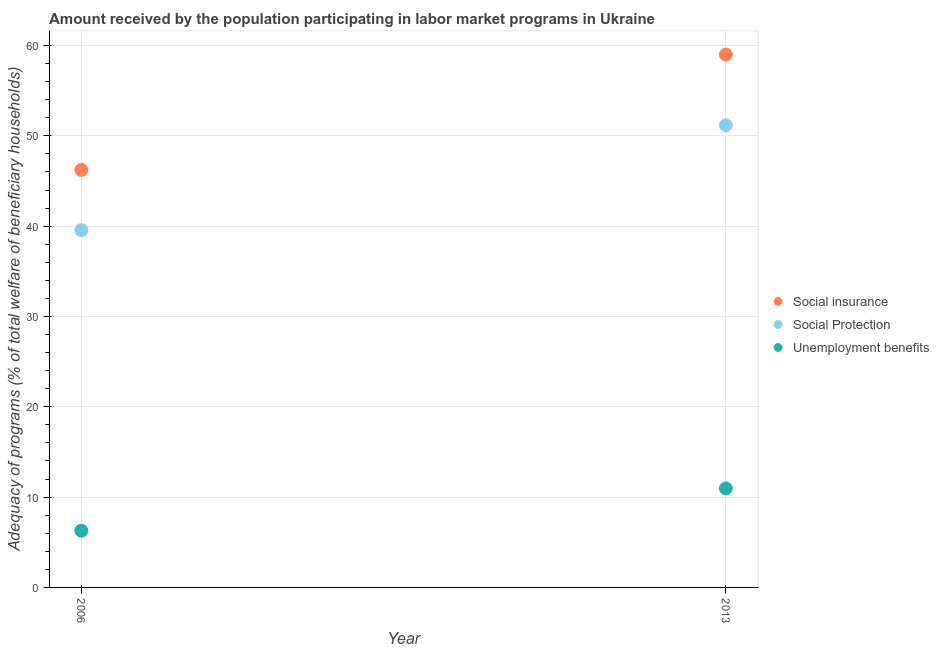How many different coloured dotlines are there?
Your answer should be very brief. 3. What is the amount received by the population participating in social insurance programs in 2006?
Offer a terse response. 46.23. Across all years, what is the maximum amount received by the population participating in social insurance programs?
Provide a short and direct response. 58.99. Across all years, what is the minimum amount received by the population participating in social insurance programs?
Give a very brief answer. 46.23. What is the total amount received by the population participating in social insurance programs in the graph?
Provide a succinct answer. 105.22. What is the difference between the amount received by the population participating in social protection programs in 2006 and that in 2013?
Provide a short and direct response. -11.61. What is the difference between the amount received by the population participating in social protection programs in 2006 and the amount received by the population participating in social insurance programs in 2013?
Make the answer very short. -19.43. What is the average amount received by the population participating in unemployment benefits programs per year?
Give a very brief answer. 8.62. In the year 2006, what is the difference between the amount received by the population participating in social protection programs and amount received by the population participating in social insurance programs?
Your answer should be compact. -6.66. In how many years, is the amount received by the population participating in social protection programs greater than 52 %?
Ensure brevity in your answer.  0. What is the ratio of the amount received by the population participating in social insurance programs in 2006 to that in 2013?
Offer a terse response. 0.78. Is the amount received by the population participating in social protection programs in 2006 less than that in 2013?
Offer a terse response. Yes. In how many years, is the amount received by the population participating in unemployment benefits programs greater than the average amount received by the population participating in unemployment benefits programs taken over all years?
Provide a succinct answer. 1. Does the amount received by the population participating in social insurance programs monotonically increase over the years?
Offer a very short reply. Yes. Is the amount received by the population participating in social protection programs strictly greater than the amount received by the population participating in social insurance programs over the years?
Ensure brevity in your answer.  No. Is the amount received by the population participating in social insurance programs strictly less than the amount received by the population participating in unemployment benefits programs over the years?
Your answer should be very brief. No. How many dotlines are there?
Offer a very short reply. 3. How many years are there in the graph?
Provide a short and direct response. 2. What is the difference between two consecutive major ticks on the Y-axis?
Your answer should be very brief. 10. Does the graph contain any zero values?
Ensure brevity in your answer.  No. Does the graph contain grids?
Your answer should be compact. Yes. Where does the legend appear in the graph?
Provide a succinct answer. Center right. How many legend labels are there?
Give a very brief answer. 3. What is the title of the graph?
Make the answer very short. Amount received by the population participating in labor market programs in Ukraine. Does "Taxes on income" appear as one of the legend labels in the graph?
Provide a succinct answer. No. What is the label or title of the Y-axis?
Provide a short and direct response. Adequacy of programs (% of total welfare of beneficiary households). What is the Adequacy of programs (% of total welfare of beneficiary households) of Social insurance in 2006?
Your response must be concise. 46.23. What is the Adequacy of programs (% of total welfare of beneficiary households) of Social Protection in 2006?
Your response must be concise. 39.56. What is the Adequacy of programs (% of total welfare of beneficiary households) in Unemployment benefits in 2006?
Your answer should be very brief. 6.28. What is the Adequacy of programs (% of total welfare of beneficiary households) in Social insurance in 2013?
Offer a very short reply. 58.99. What is the Adequacy of programs (% of total welfare of beneficiary households) of Social Protection in 2013?
Your response must be concise. 51.17. What is the Adequacy of programs (% of total welfare of beneficiary households) of Unemployment benefits in 2013?
Give a very brief answer. 10.96. Across all years, what is the maximum Adequacy of programs (% of total welfare of beneficiary households) of Social insurance?
Ensure brevity in your answer.  58.99. Across all years, what is the maximum Adequacy of programs (% of total welfare of beneficiary households) of Social Protection?
Ensure brevity in your answer.  51.17. Across all years, what is the maximum Adequacy of programs (% of total welfare of beneficiary households) in Unemployment benefits?
Offer a terse response. 10.96. Across all years, what is the minimum Adequacy of programs (% of total welfare of beneficiary households) in Social insurance?
Offer a very short reply. 46.23. Across all years, what is the minimum Adequacy of programs (% of total welfare of beneficiary households) of Social Protection?
Provide a succinct answer. 39.56. Across all years, what is the minimum Adequacy of programs (% of total welfare of beneficiary households) of Unemployment benefits?
Make the answer very short. 6.28. What is the total Adequacy of programs (% of total welfare of beneficiary households) of Social insurance in the graph?
Give a very brief answer. 105.22. What is the total Adequacy of programs (% of total welfare of beneficiary households) in Social Protection in the graph?
Give a very brief answer. 90.73. What is the total Adequacy of programs (% of total welfare of beneficiary households) of Unemployment benefits in the graph?
Provide a succinct answer. 17.24. What is the difference between the Adequacy of programs (% of total welfare of beneficiary households) in Social insurance in 2006 and that in 2013?
Give a very brief answer. -12.77. What is the difference between the Adequacy of programs (% of total welfare of beneficiary households) of Social Protection in 2006 and that in 2013?
Your answer should be very brief. -11.61. What is the difference between the Adequacy of programs (% of total welfare of beneficiary households) in Unemployment benefits in 2006 and that in 2013?
Provide a short and direct response. -4.68. What is the difference between the Adequacy of programs (% of total welfare of beneficiary households) in Social insurance in 2006 and the Adequacy of programs (% of total welfare of beneficiary households) in Social Protection in 2013?
Give a very brief answer. -4.94. What is the difference between the Adequacy of programs (% of total welfare of beneficiary households) of Social insurance in 2006 and the Adequacy of programs (% of total welfare of beneficiary households) of Unemployment benefits in 2013?
Offer a very short reply. 35.26. What is the difference between the Adequacy of programs (% of total welfare of beneficiary households) in Social Protection in 2006 and the Adequacy of programs (% of total welfare of beneficiary households) in Unemployment benefits in 2013?
Your response must be concise. 28.6. What is the average Adequacy of programs (% of total welfare of beneficiary households) of Social insurance per year?
Your response must be concise. 52.61. What is the average Adequacy of programs (% of total welfare of beneficiary households) of Social Protection per year?
Your answer should be compact. 45.37. What is the average Adequacy of programs (% of total welfare of beneficiary households) of Unemployment benefits per year?
Ensure brevity in your answer.  8.62. In the year 2006, what is the difference between the Adequacy of programs (% of total welfare of beneficiary households) in Social insurance and Adequacy of programs (% of total welfare of beneficiary households) in Social Protection?
Your answer should be compact. 6.66. In the year 2006, what is the difference between the Adequacy of programs (% of total welfare of beneficiary households) in Social insurance and Adequacy of programs (% of total welfare of beneficiary households) in Unemployment benefits?
Provide a short and direct response. 39.95. In the year 2006, what is the difference between the Adequacy of programs (% of total welfare of beneficiary households) in Social Protection and Adequacy of programs (% of total welfare of beneficiary households) in Unemployment benefits?
Give a very brief answer. 33.28. In the year 2013, what is the difference between the Adequacy of programs (% of total welfare of beneficiary households) in Social insurance and Adequacy of programs (% of total welfare of beneficiary households) in Social Protection?
Ensure brevity in your answer.  7.82. In the year 2013, what is the difference between the Adequacy of programs (% of total welfare of beneficiary households) of Social insurance and Adequacy of programs (% of total welfare of beneficiary households) of Unemployment benefits?
Make the answer very short. 48.03. In the year 2013, what is the difference between the Adequacy of programs (% of total welfare of beneficiary households) in Social Protection and Adequacy of programs (% of total welfare of beneficiary households) in Unemployment benefits?
Your response must be concise. 40.21. What is the ratio of the Adequacy of programs (% of total welfare of beneficiary households) of Social insurance in 2006 to that in 2013?
Provide a succinct answer. 0.78. What is the ratio of the Adequacy of programs (% of total welfare of beneficiary households) in Social Protection in 2006 to that in 2013?
Ensure brevity in your answer.  0.77. What is the ratio of the Adequacy of programs (% of total welfare of beneficiary households) in Unemployment benefits in 2006 to that in 2013?
Make the answer very short. 0.57. What is the difference between the highest and the second highest Adequacy of programs (% of total welfare of beneficiary households) of Social insurance?
Your response must be concise. 12.77. What is the difference between the highest and the second highest Adequacy of programs (% of total welfare of beneficiary households) in Social Protection?
Offer a terse response. 11.61. What is the difference between the highest and the second highest Adequacy of programs (% of total welfare of beneficiary households) of Unemployment benefits?
Your response must be concise. 4.68. What is the difference between the highest and the lowest Adequacy of programs (% of total welfare of beneficiary households) in Social insurance?
Offer a terse response. 12.77. What is the difference between the highest and the lowest Adequacy of programs (% of total welfare of beneficiary households) in Social Protection?
Offer a terse response. 11.61. What is the difference between the highest and the lowest Adequacy of programs (% of total welfare of beneficiary households) in Unemployment benefits?
Offer a terse response. 4.68. 